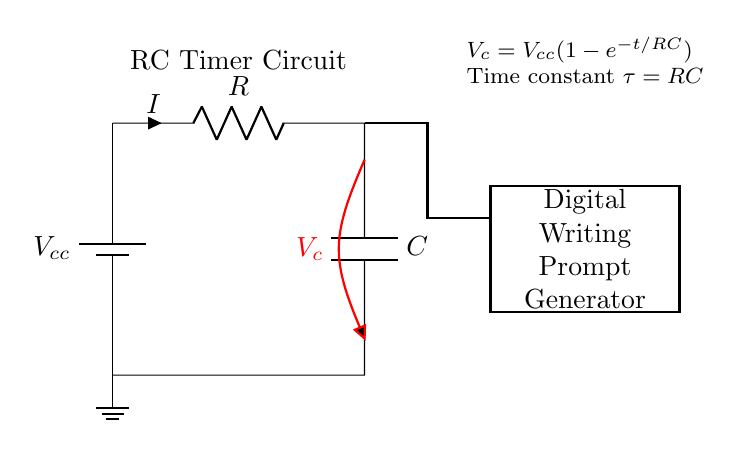What components are present in this circuit? The circuit contains a resistor, a capacitor, a battery, and a microcontroller. Each component is represented with its respective symbols, identified as R for the resistor and C for the capacitor.
Answer: Resistor, Capacitor, Battery, Microcontroller What is the voltage across the capacitor in this circuit? The voltage across the capacitor, denoted as V_c, represents the potential difference across the capacitor terminals and is indicated in red on the diagram. While the specific voltage value is not provided, it is defined by the formula V_c = V_cc(1-e^{-t/RC}).
Answer: V_c What is the time constant of the RC circuit? The time constant of the RC circuit, denoted as τ, is calculated as the product of resistance (R) and capacitance (C). This relationship is fundamental in determining the charging and discharging time of the capacitor.
Answer: RC How does increasing the resistance affect the charging time of the capacitor? Increasing the resistance (R) results in a higher time constant (τ = RC), which directly increases the time it takes for the capacitor to charge up to a certain voltage. This means the charging process will slow down, causing the time required for the voltage across the capacitor to reach its maximum to be extended.
Answer: Slower charging time What role does the microcontroller play in this RC circuit? The microcontroller is connected to the capacitor to measure or control the voltage (V_c) for the digital writing prompt generator. It typically processes signals and can generate prompts based on the voltage across the capacitor over time, potentially using this to create timing intervals for prompts.
Answer: Signal processing 